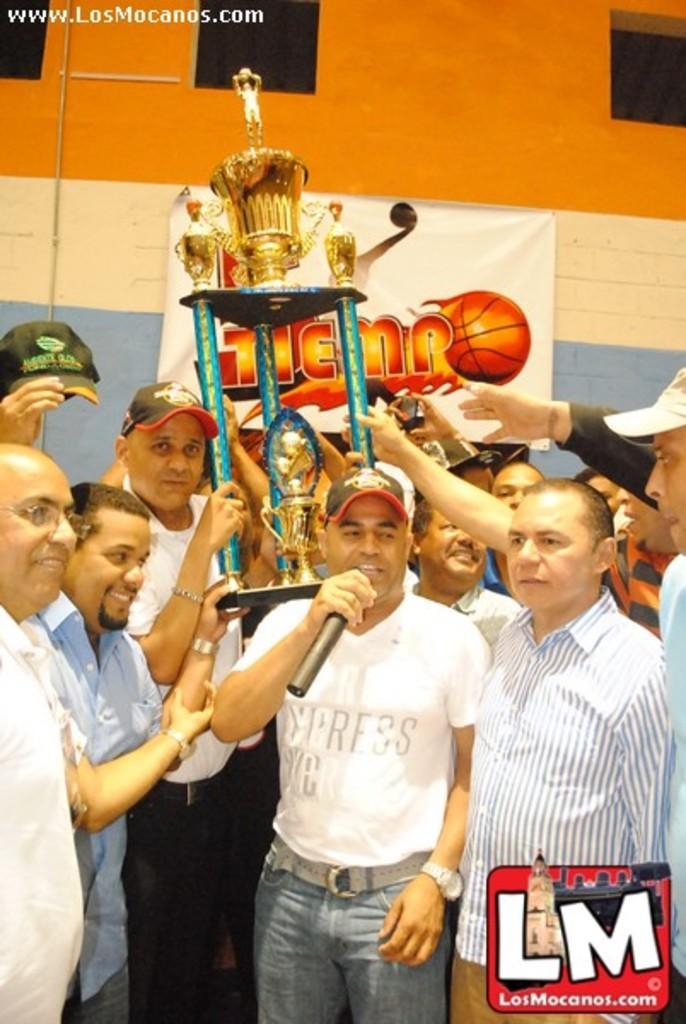How would you summarize this image in a sentence or two? In this image there are group of people standing together in which one of them is talking in microphone and all of them is holding trophy. 